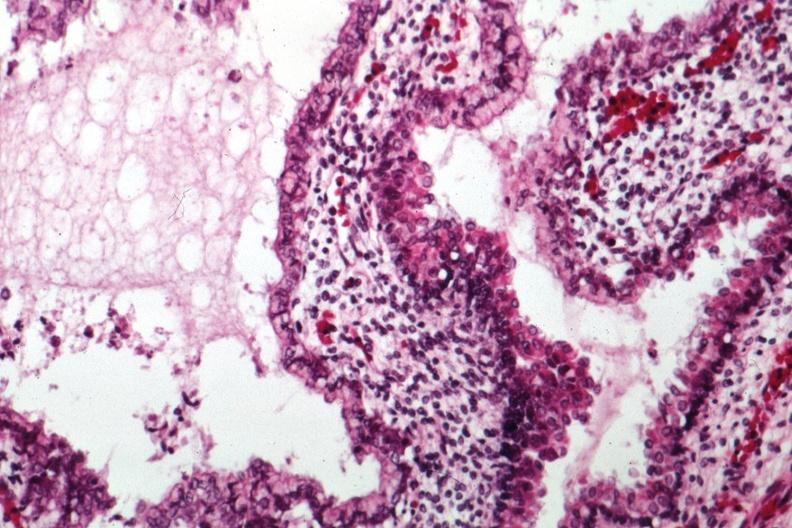s sacrococcygeal teratoma present?
Answer the question using a single word or phrase. Yes 